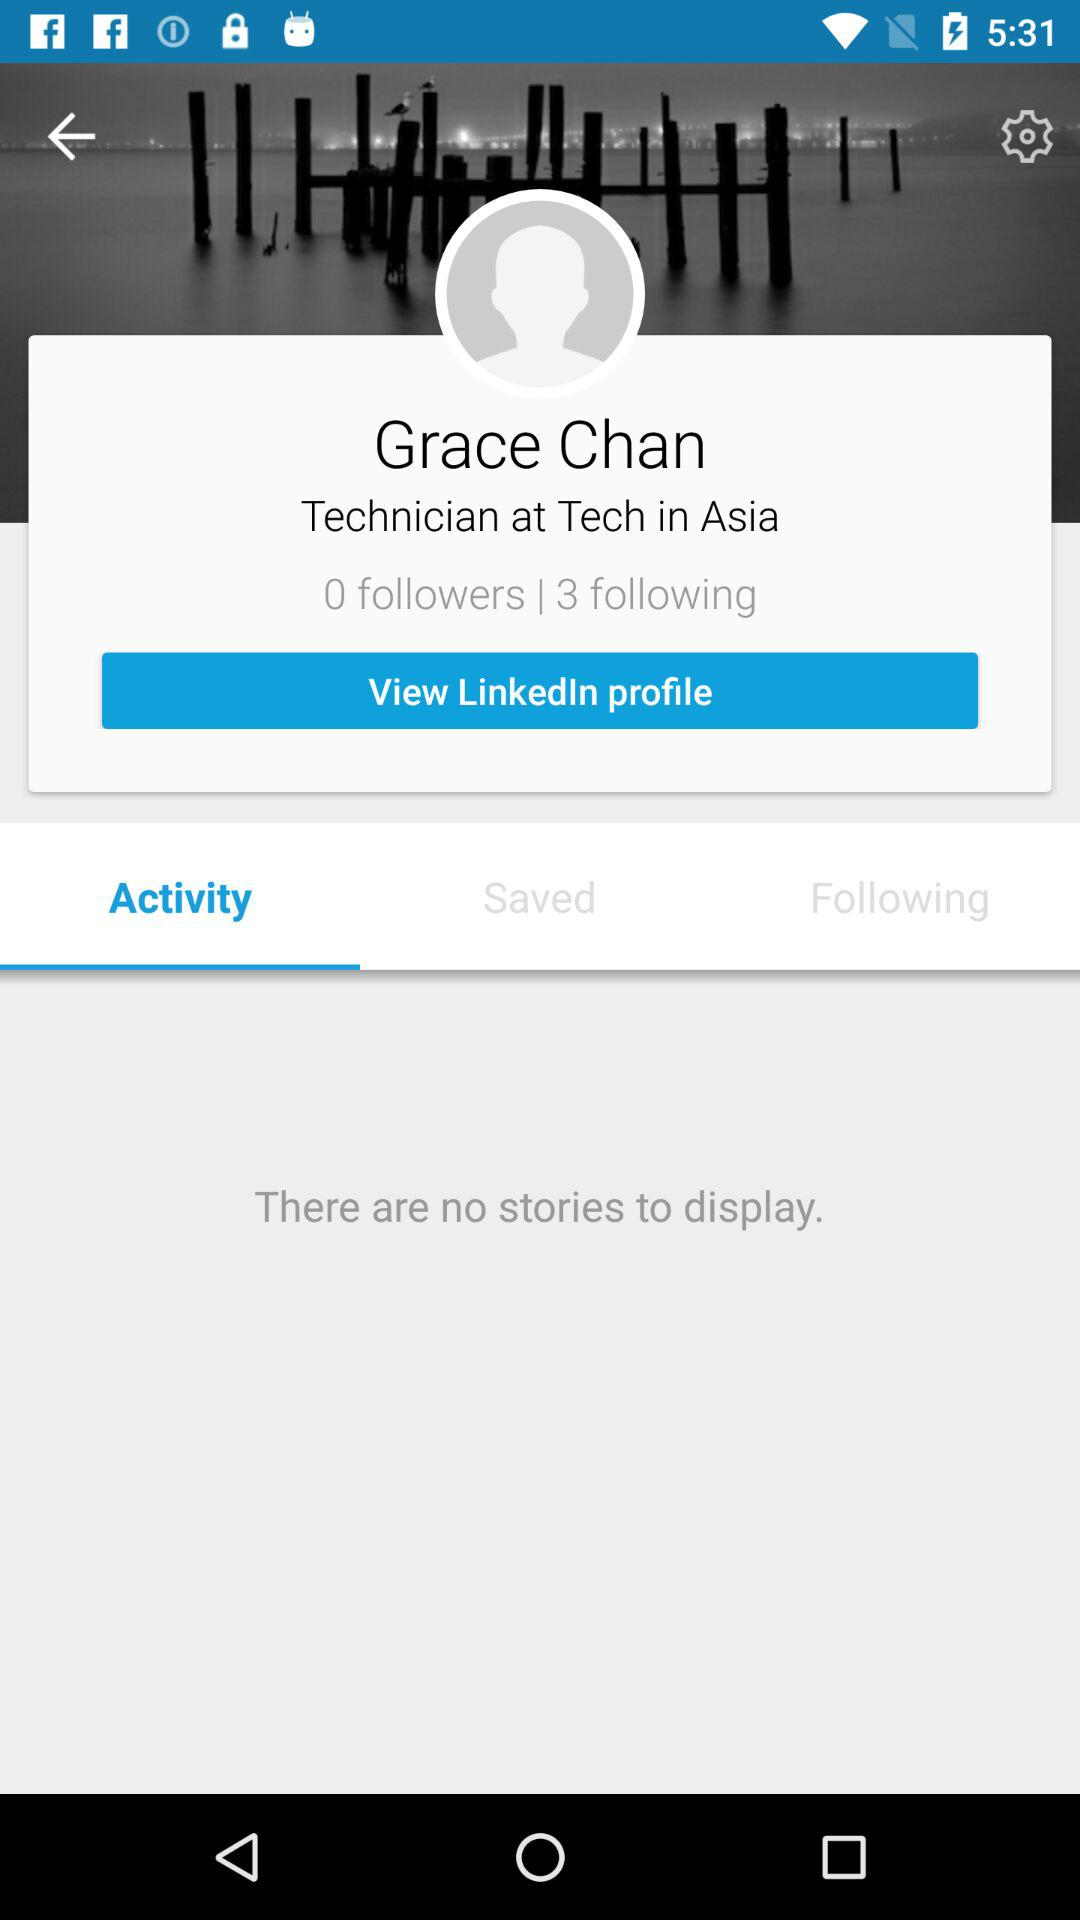What is the number of the following? The number of the following is 3. 